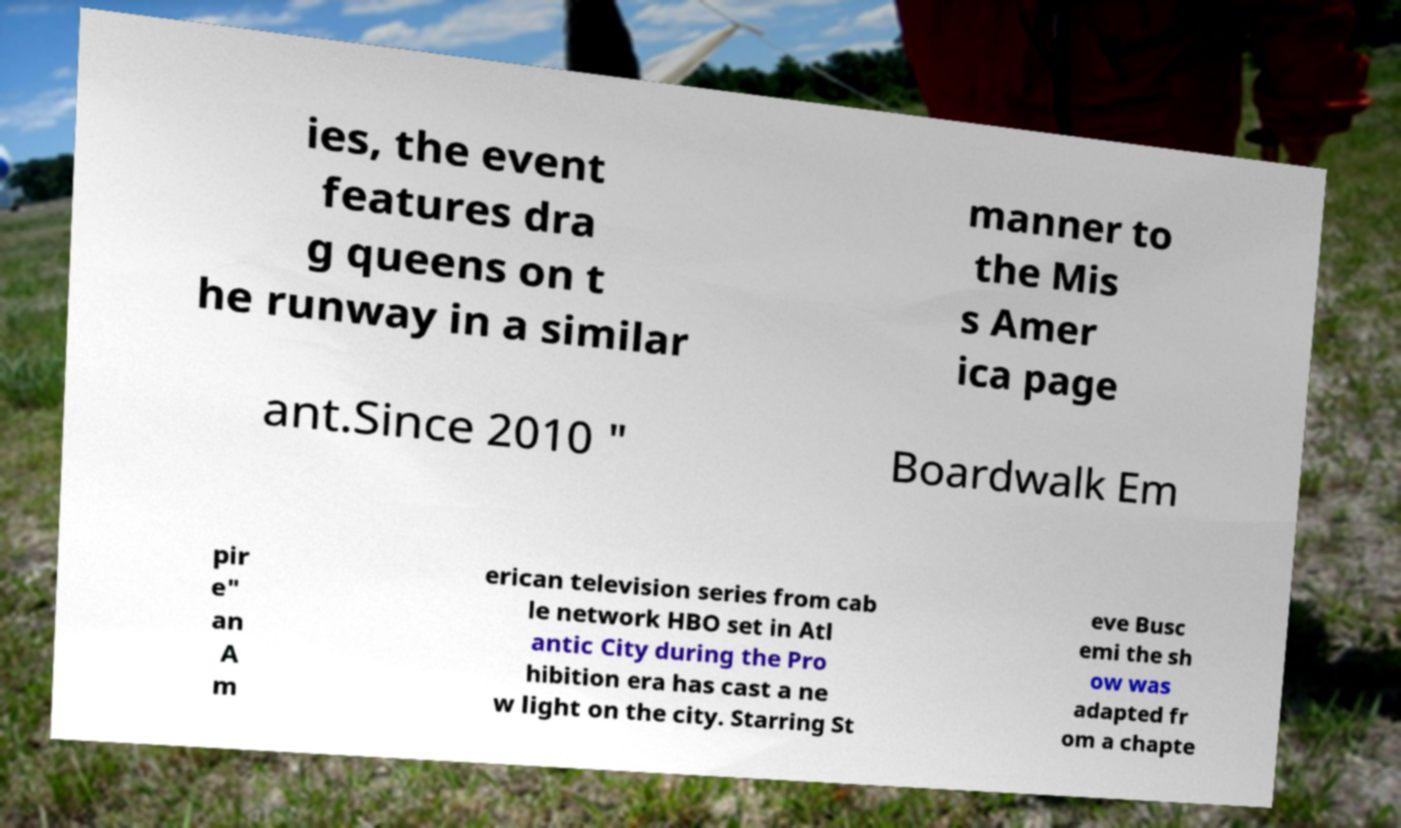There's text embedded in this image that I need extracted. Can you transcribe it verbatim? ies, the event features dra g queens on t he runway in a similar manner to the Mis s Amer ica page ant.Since 2010 " Boardwalk Em pir e" an A m erican television series from cab le network HBO set in Atl antic City during the Pro hibition era has cast a ne w light on the city. Starring St eve Busc emi the sh ow was adapted fr om a chapte 